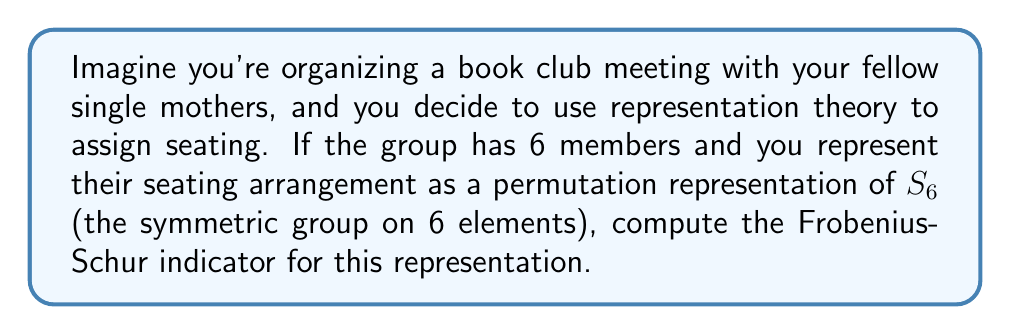Show me your answer to this math problem. Let's approach this step-by-step:

1) The Frobenius-Schur indicator for a representation $\rho$ of a finite group $G$ is given by:

   $$\nu(\rho) = \frac{1}{|G|} \sum_{g \in G} \chi_\rho(g^2)$$

   where $\chi_\rho$ is the character of the representation and $|G|$ is the order of the group.

2) In our case, $G = S_6$, the symmetric group on 6 elements. The order of $S_6$ is $6! = 720$.

3) The permutation representation of $S_6$ acting on 6 elements is the standard representation. Its character $\chi$ is given by:

   $\chi(\sigma) = \text{number of fixed points of } \sigma$

4) To compute $\sum_{g \in G} \chi(g^2)$, we need to consider the cycle structure of $g^2$ for each $g \in S_6$.

5) The key observation is that squaring a permutation has the following effect on its cycle structure:
   - Cycles of odd length remain unchanged
   - Cycles of even length split into two cycles of half the length

6) Therefore, the only elements that contribute to the sum are those where $g^2$ has fixed points, which are:
   - The identity element (contributes 6)
   - 3-cycles (contribute 3 each, there are 40 of them)
   - (2,2)-cycles (contribute 2 each, there are 45 of them)
   - 2-cycles (contribute 4 each, there are 15 of them)

7) Summing these up:

   $\sum_{g \in S_6} \chi(g^2) = 6 + 40 \cdot 3 + 45 \cdot 2 + 15 \cdot 4 = 246$

8) Therefore, the Frobenius-Schur indicator is:

   $$\nu(\rho) = \frac{1}{720} \cdot 246 = \frac{41}{120}$$
Answer: $\frac{41}{120}$ 